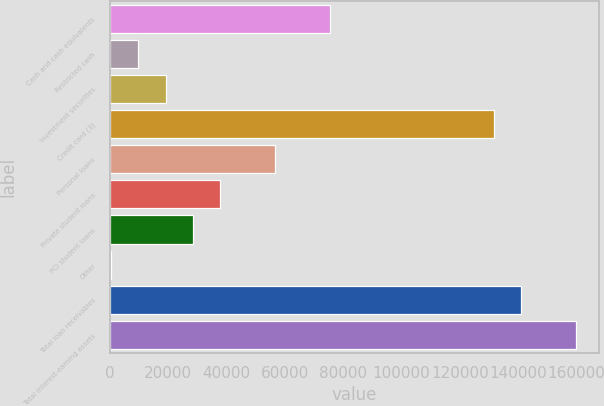Convert chart to OTSL. <chart><loc_0><loc_0><loc_500><loc_500><bar_chart><fcel>Cash and cash equivalents<fcel>Restricted cash<fcel>Investment securities<fcel>Credit card (3)<fcel>Personal loans<fcel>Private student loans<fcel>PCI student loans<fcel>Other<fcel>Total loan receivables<fcel>Total interest-earning assets<nl><fcel>75360.8<fcel>9714.1<fcel>19092.2<fcel>131629<fcel>56604.6<fcel>37848.4<fcel>28470.3<fcel>336<fcel>141008<fcel>159764<nl></chart> 